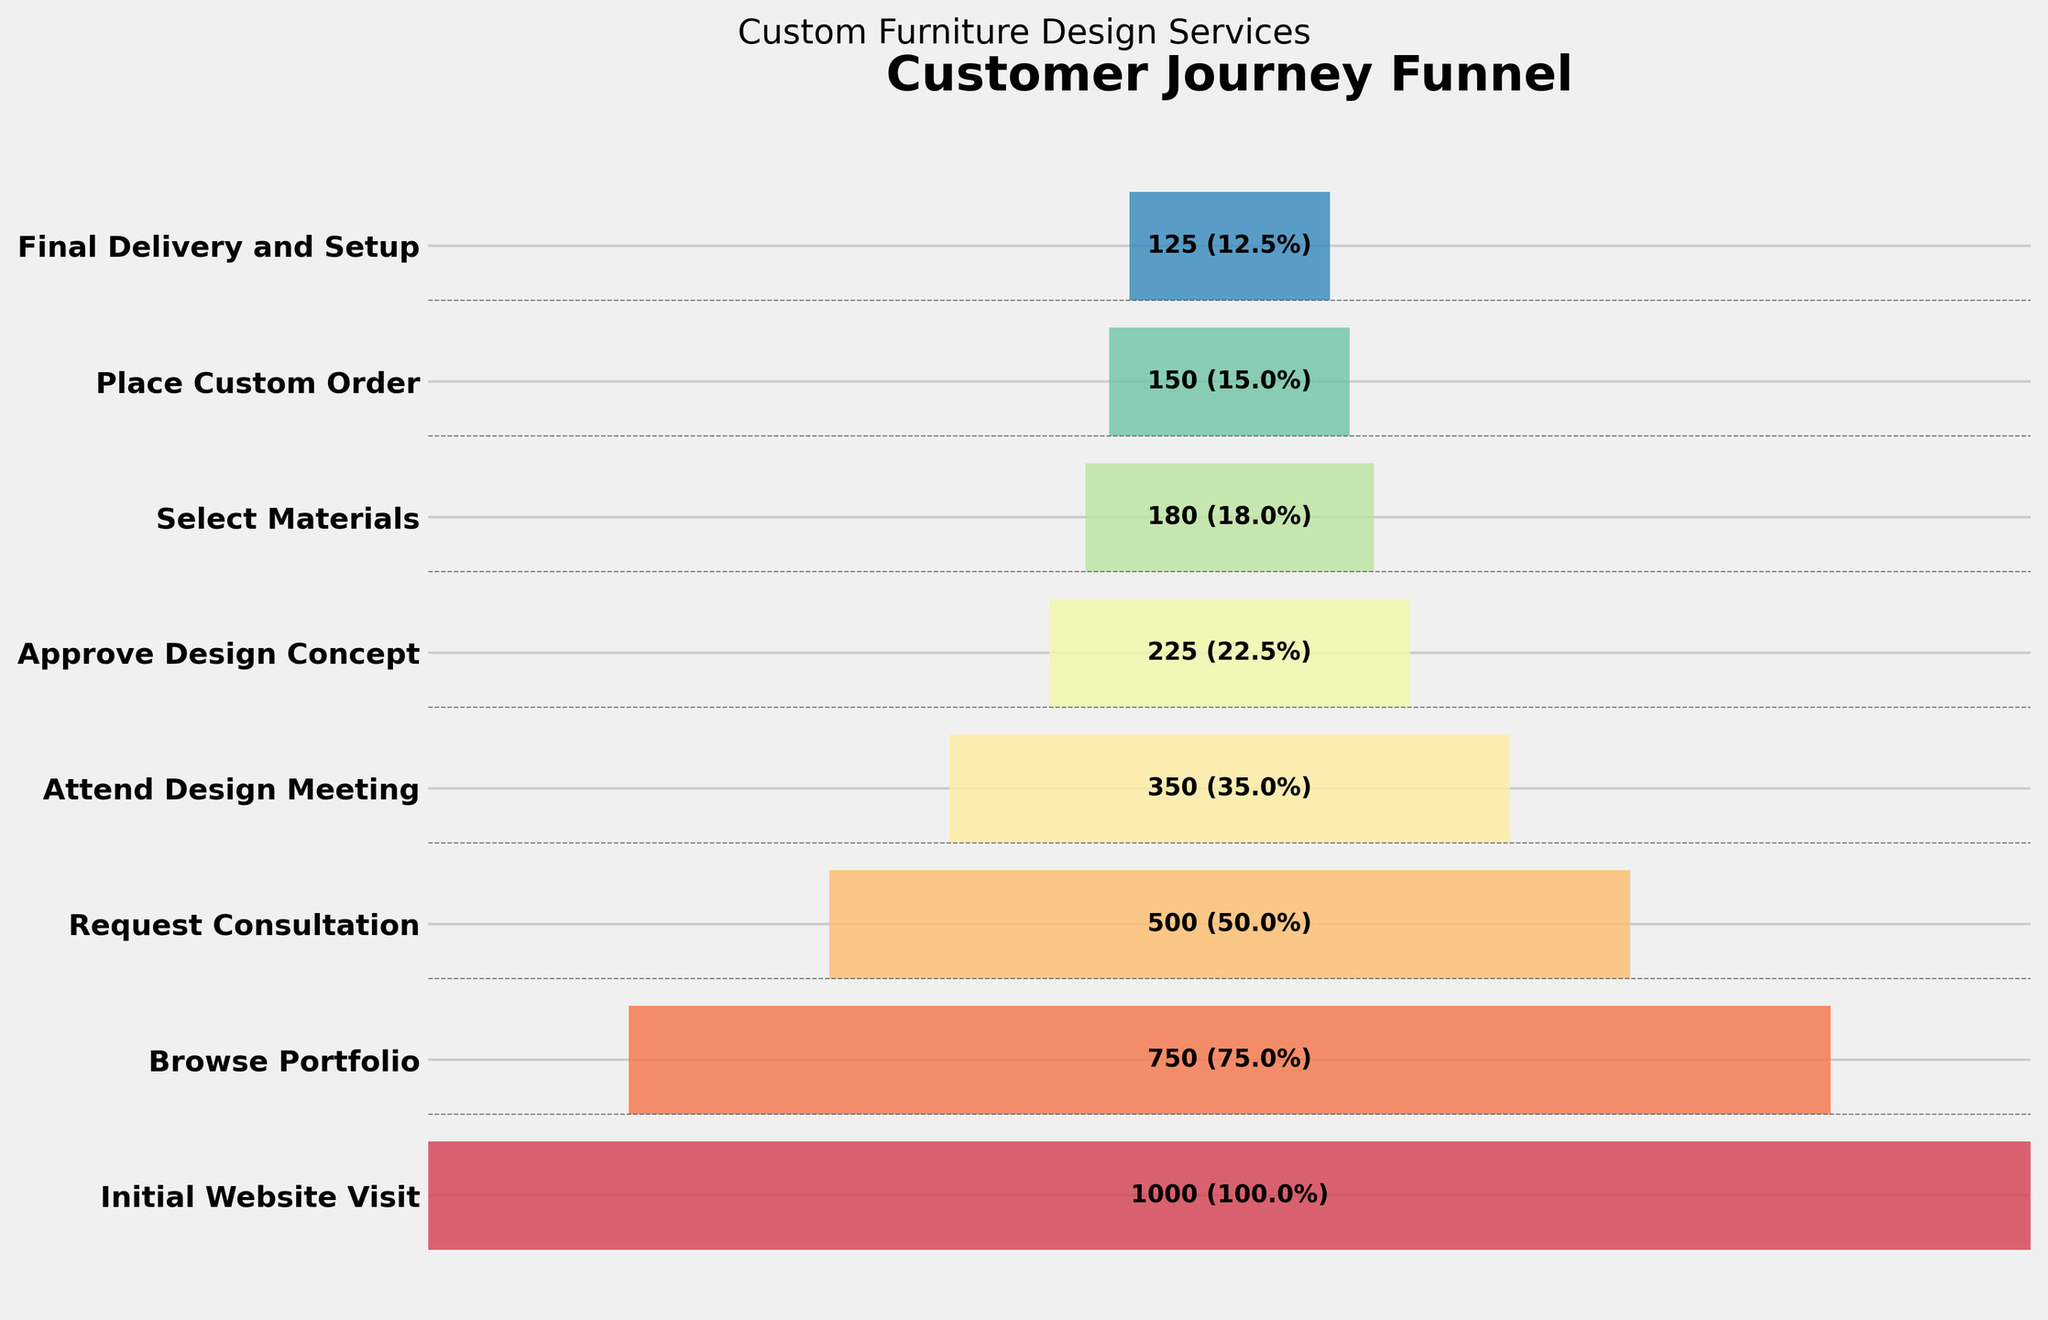What is the title of the funnel chart? The title appears at the top of the funnel chart and is typically the most prominent text. The title in this chart is "Customer Journey Funnel".
Answer: Customer Journey Funnel At which stage do we see 225 customers? The chart shows various stages on the vertical axis with corresponding customer numbers labeled. The "Approve Design Concept" stage has 225 customers.
Answer: Approve Design Concept How many customers attended the Design Meeting? From the chart, the number of customers attending the Design Meeting is shown next to the "Attend Design Meeting" stage as 350.
Answer: 350 What percentage of the initial website visitors placed a custom order? First, locate the number of customers who placed a custom order (150) and the initial website visitors (1000). Then, calculate the percentage: (150 / 1000) * 100% = 15%.
Answer: 15% Which stage has the most significant drop in the number of customers? Find the stage transitions with the largest numerical drop in customer count. The largest drop is from "Request Consultation" (500) to "Attend Design Meeting" (350), showing a drop of 150 customers.
Answer: Request Consultation to Attend Design Meeting What's the difference between the number of customers who approved the design concept and those who selected materials? Locate the customer counts for "Approve Design Concept" (225) and "Select Materials" (180). The difference is 225 - 180 = 45.
Answer: 45 How many stages are represented in the funnel chart? Count the number of different stages labeled on the vertical axis. There are 8 stages from top to bottom of the chart.
Answer: 8 At which stage do half of the initial visitors drop off? Half of the initial visitors means 50% of 1000 = 500. The stage where there are around 500 (or slightly less) customers remaining is "Request Consultation" which has exactly 500 customers.
Answer: Request Consultation Which stage immediately follows "Browse Portfolio"? The next stage after "Browse Portfolio" should be identified as the one directly below it on the chart. It is "Request Consultation".
Answer: Request Consultation Is the number of customers who approve the design concept greater than the number who place the custom order? Compare the number of customers who approve the design concept (225) with those who place the custom order (150). 225 is greater than 150.
Answer: Yes 